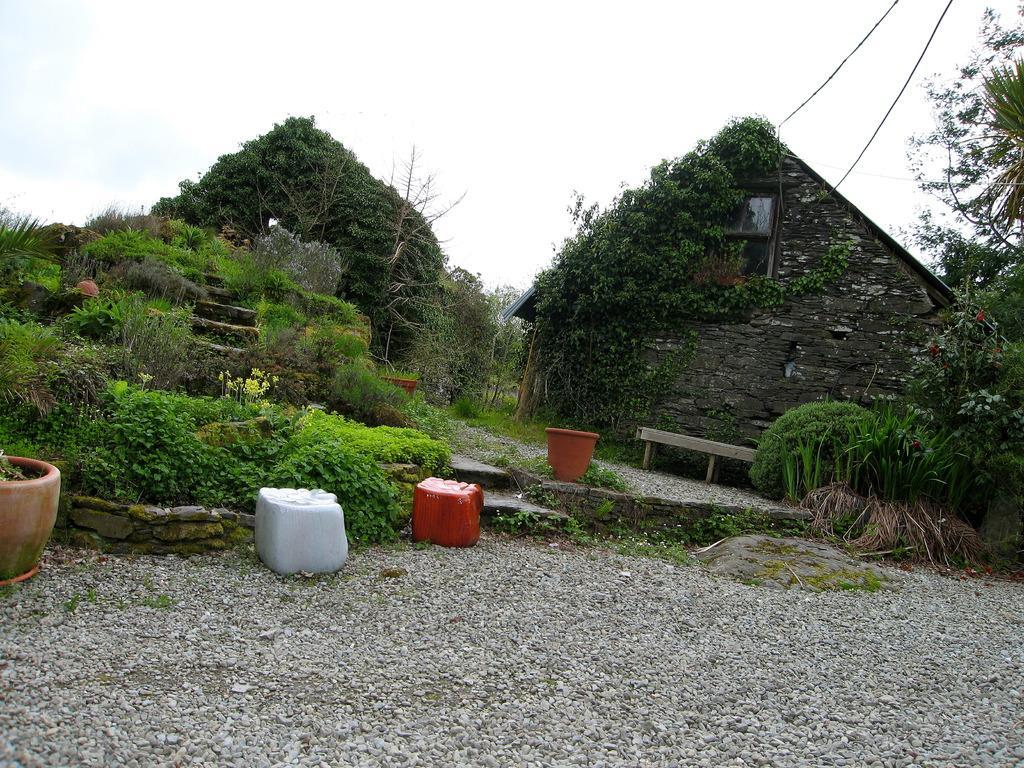Can you describe this image briefly? In this image there is a house, there are plants, pots, trees, stones, and in the background there is sky. 